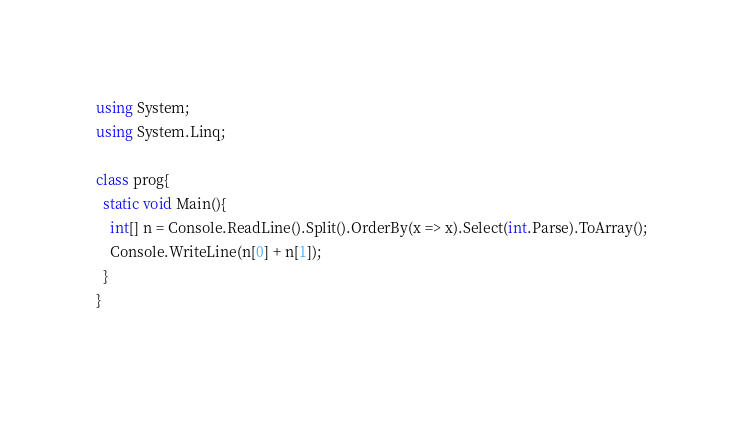<code> <loc_0><loc_0><loc_500><loc_500><_C#_>using System;
using System.Linq;

class prog{
  static void Main(){
    int[] n = Console.ReadLine().Split().OrderBy(x => x).Select(int.Parse).ToArray();
    Console.WriteLine(n[0] + n[1]);
  }
}
    </code> 